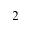<formula> <loc_0><loc_0><loc_500><loc_500>^ { 2 }</formula> 